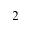<formula> <loc_0><loc_0><loc_500><loc_500>^ { 2 }</formula> 